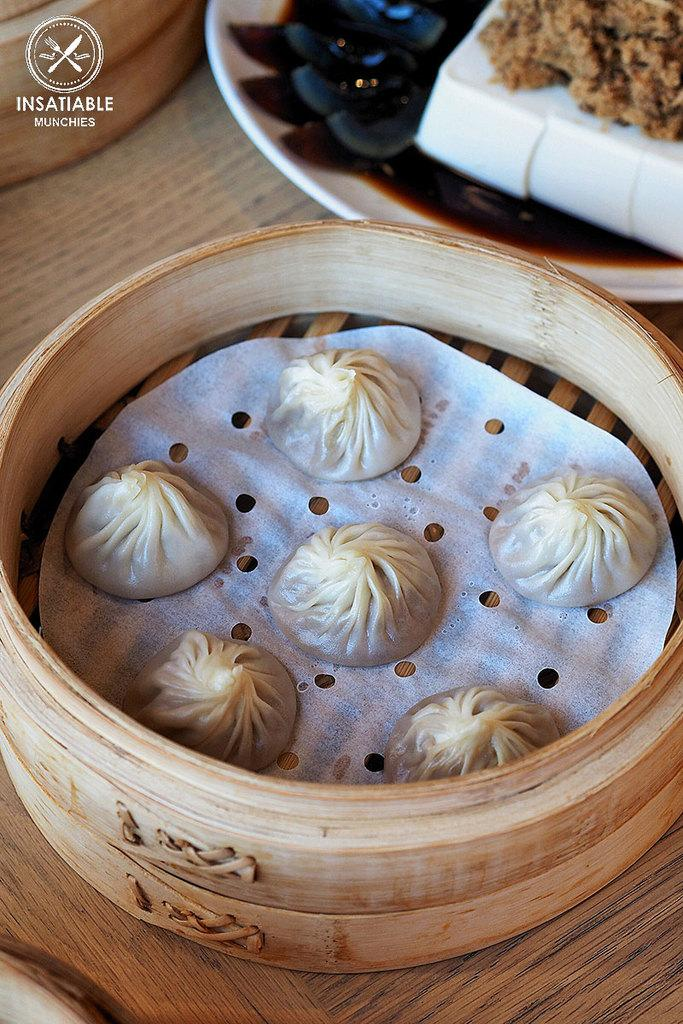What type of food is visible in the image? There are momos in the image. What is the momos placed on? There is a plate in the image. What is on top of the plate? There is a food item on the plate. Is there a volcano erupting in the image? No, there is no volcano or any indication of an eruption in the image. 